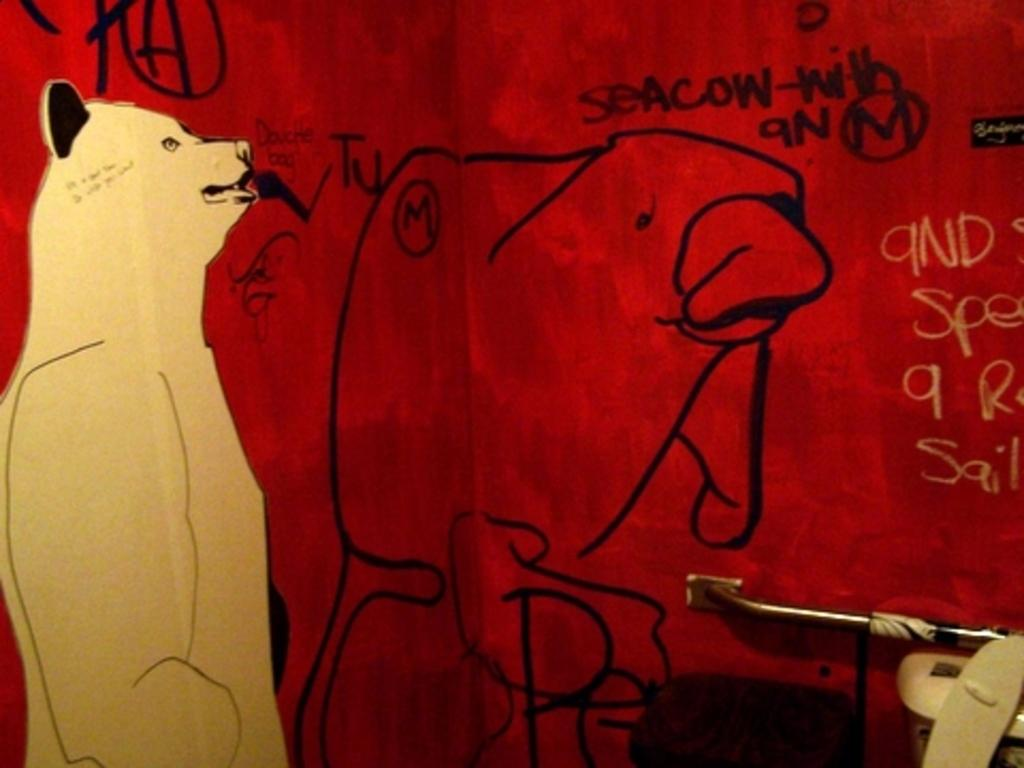What is on the wall in the image? There is a painting and text on the wall in the image. Can you describe the painting? Unfortunately, the facts provided do not give a detailed description of the painting. What is located on the right side bottom of the image? There is a rod on the right side bottom of the image. What objects are near the rod in the image? The facts provided do not specify which objects are near the rod. How many wrens are perched on the rod in the image? There are no wrens present in the image. What type of bone is visible near the rod in the image? There are no bones visible in the image. 